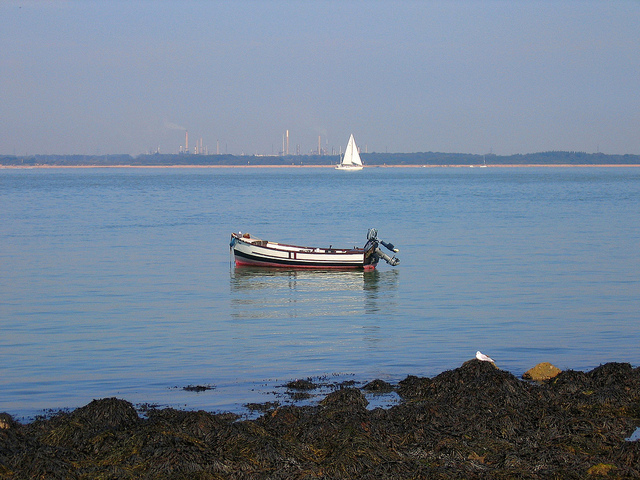How many cars are to the left of the bus? 0 